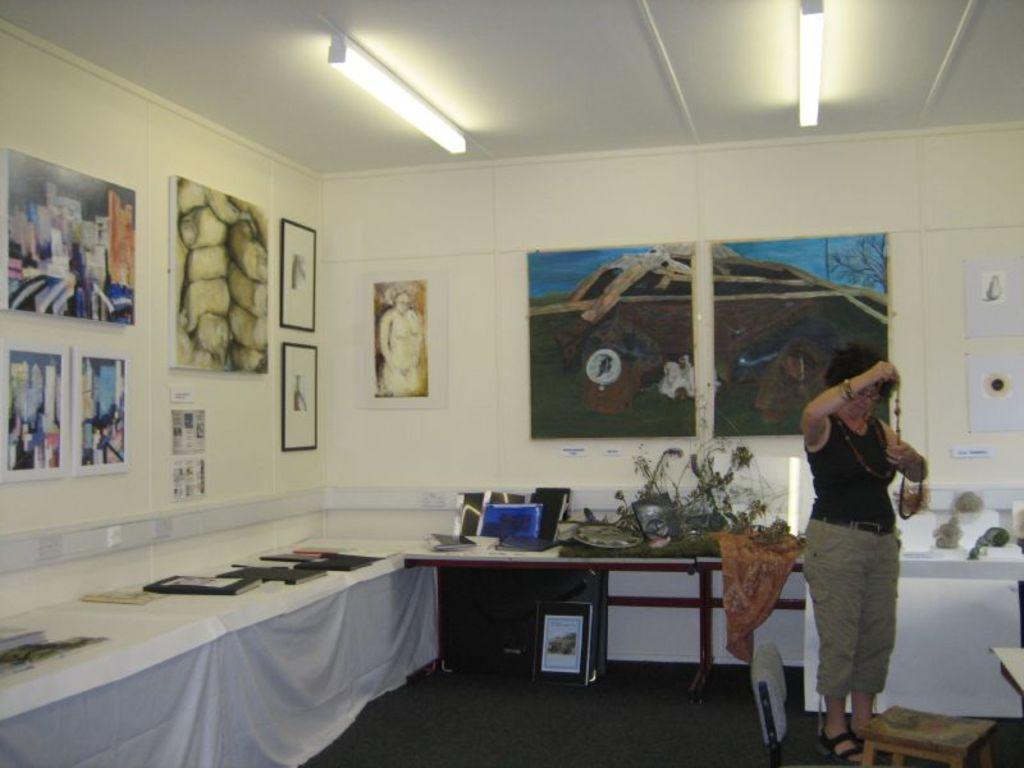Can you describe this image briefly? In this image we can see a woman is standing. She is wearing black top and grey pant. Behind her table is there. On table so many different things are arranged. We can see paintings are attached to the white wall. At the top of the image, roof is there and lights are attached to the roof. At the right bottom of the image, one table is present. 